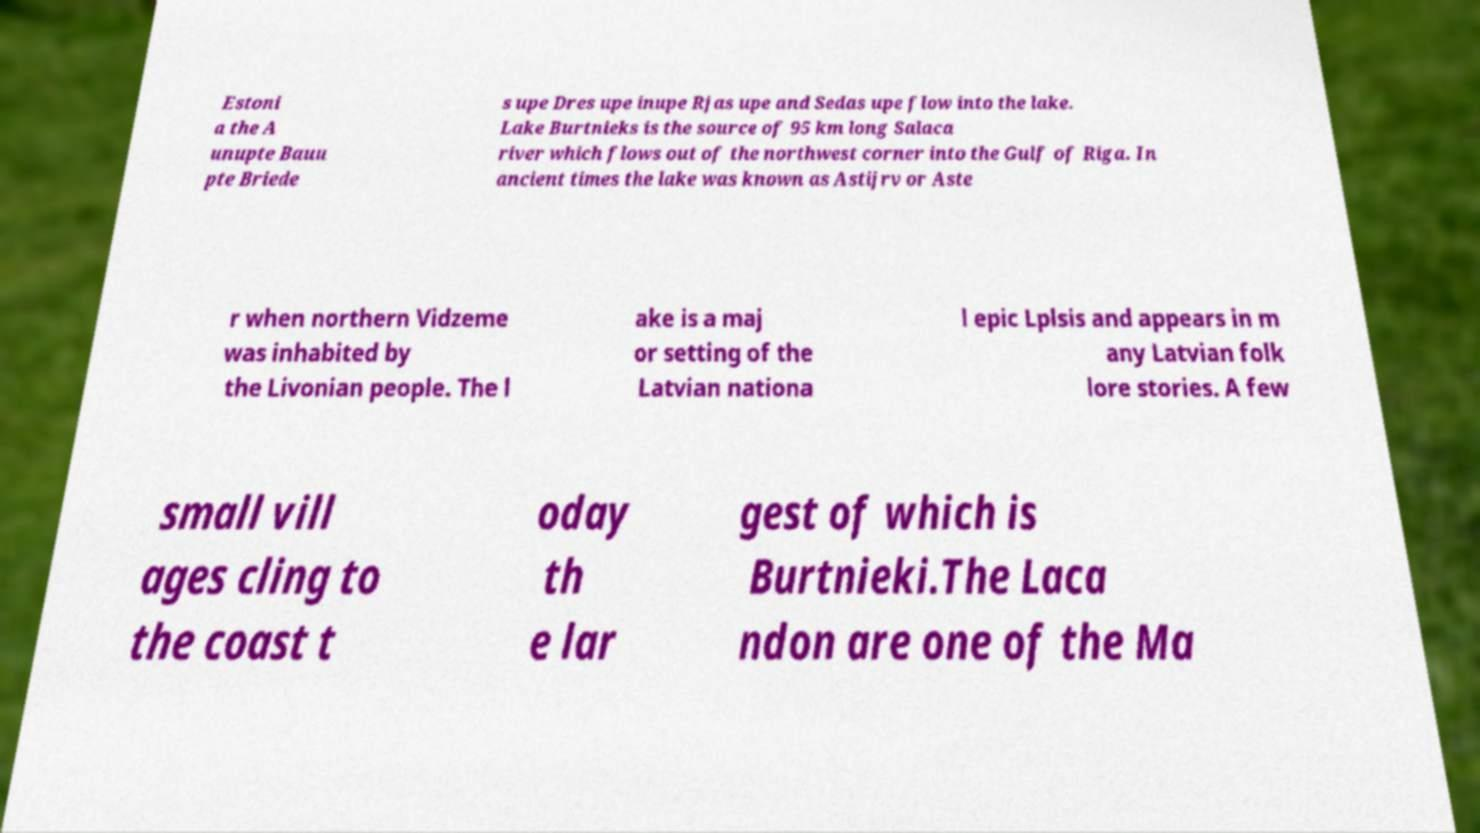Can you accurately transcribe the text from the provided image for me? Estoni a the A unupte Bauu pte Briede s upe Dres upe inupe Rjas upe and Sedas upe flow into the lake. Lake Burtnieks is the source of 95 km long Salaca river which flows out of the northwest corner into the Gulf of Riga. In ancient times the lake was known as Astijrv or Aste r when northern Vidzeme was inhabited by the Livonian people. The l ake is a maj or setting of the Latvian nationa l epic Lplsis and appears in m any Latvian folk lore stories. A few small vill ages cling to the coast t oday th e lar gest of which is Burtnieki.The Laca ndon are one of the Ma 